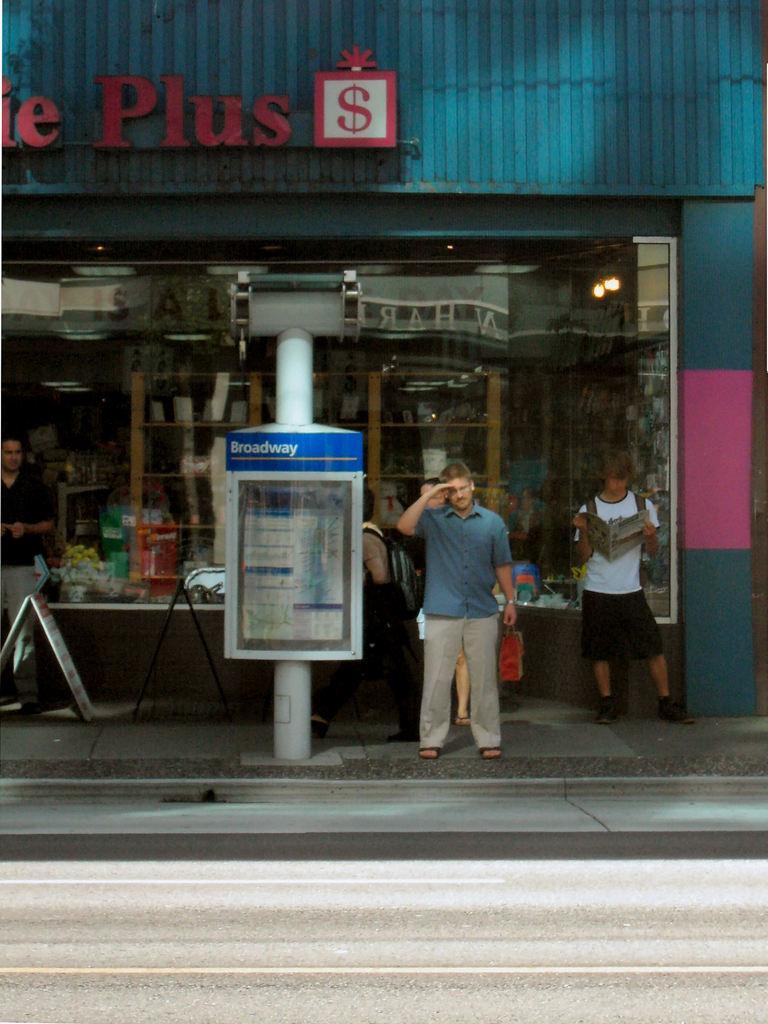Please provide a concise description of this image. The man in the blue shirt is standing on the sideways and he is saluting. Behind him, the boy in white T-shirt is reading the newspaper. Beside the man, we see a pole and a board with some text written on it. Behind that, we see a building in blue color and on the building, we see some text written. At the bottom of the picture, we see the road. 